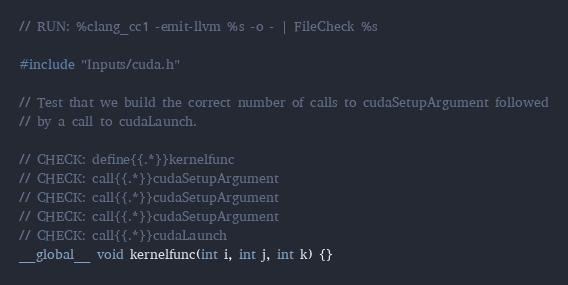<code> <loc_0><loc_0><loc_500><loc_500><_Cuda_>// RUN: %clang_cc1 -emit-llvm %s -o - | FileCheck %s

#include "Inputs/cuda.h"

// Test that we build the correct number of calls to cudaSetupArgument followed
// by a call to cudaLaunch.

// CHECK: define{{.*}}kernelfunc
// CHECK: call{{.*}}cudaSetupArgument
// CHECK: call{{.*}}cudaSetupArgument
// CHECK: call{{.*}}cudaSetupArgument
// CHECK: call{{.*}}cudaLaunch
__global__ void kernelfunc(int i, int j, int k) {}
</code> 